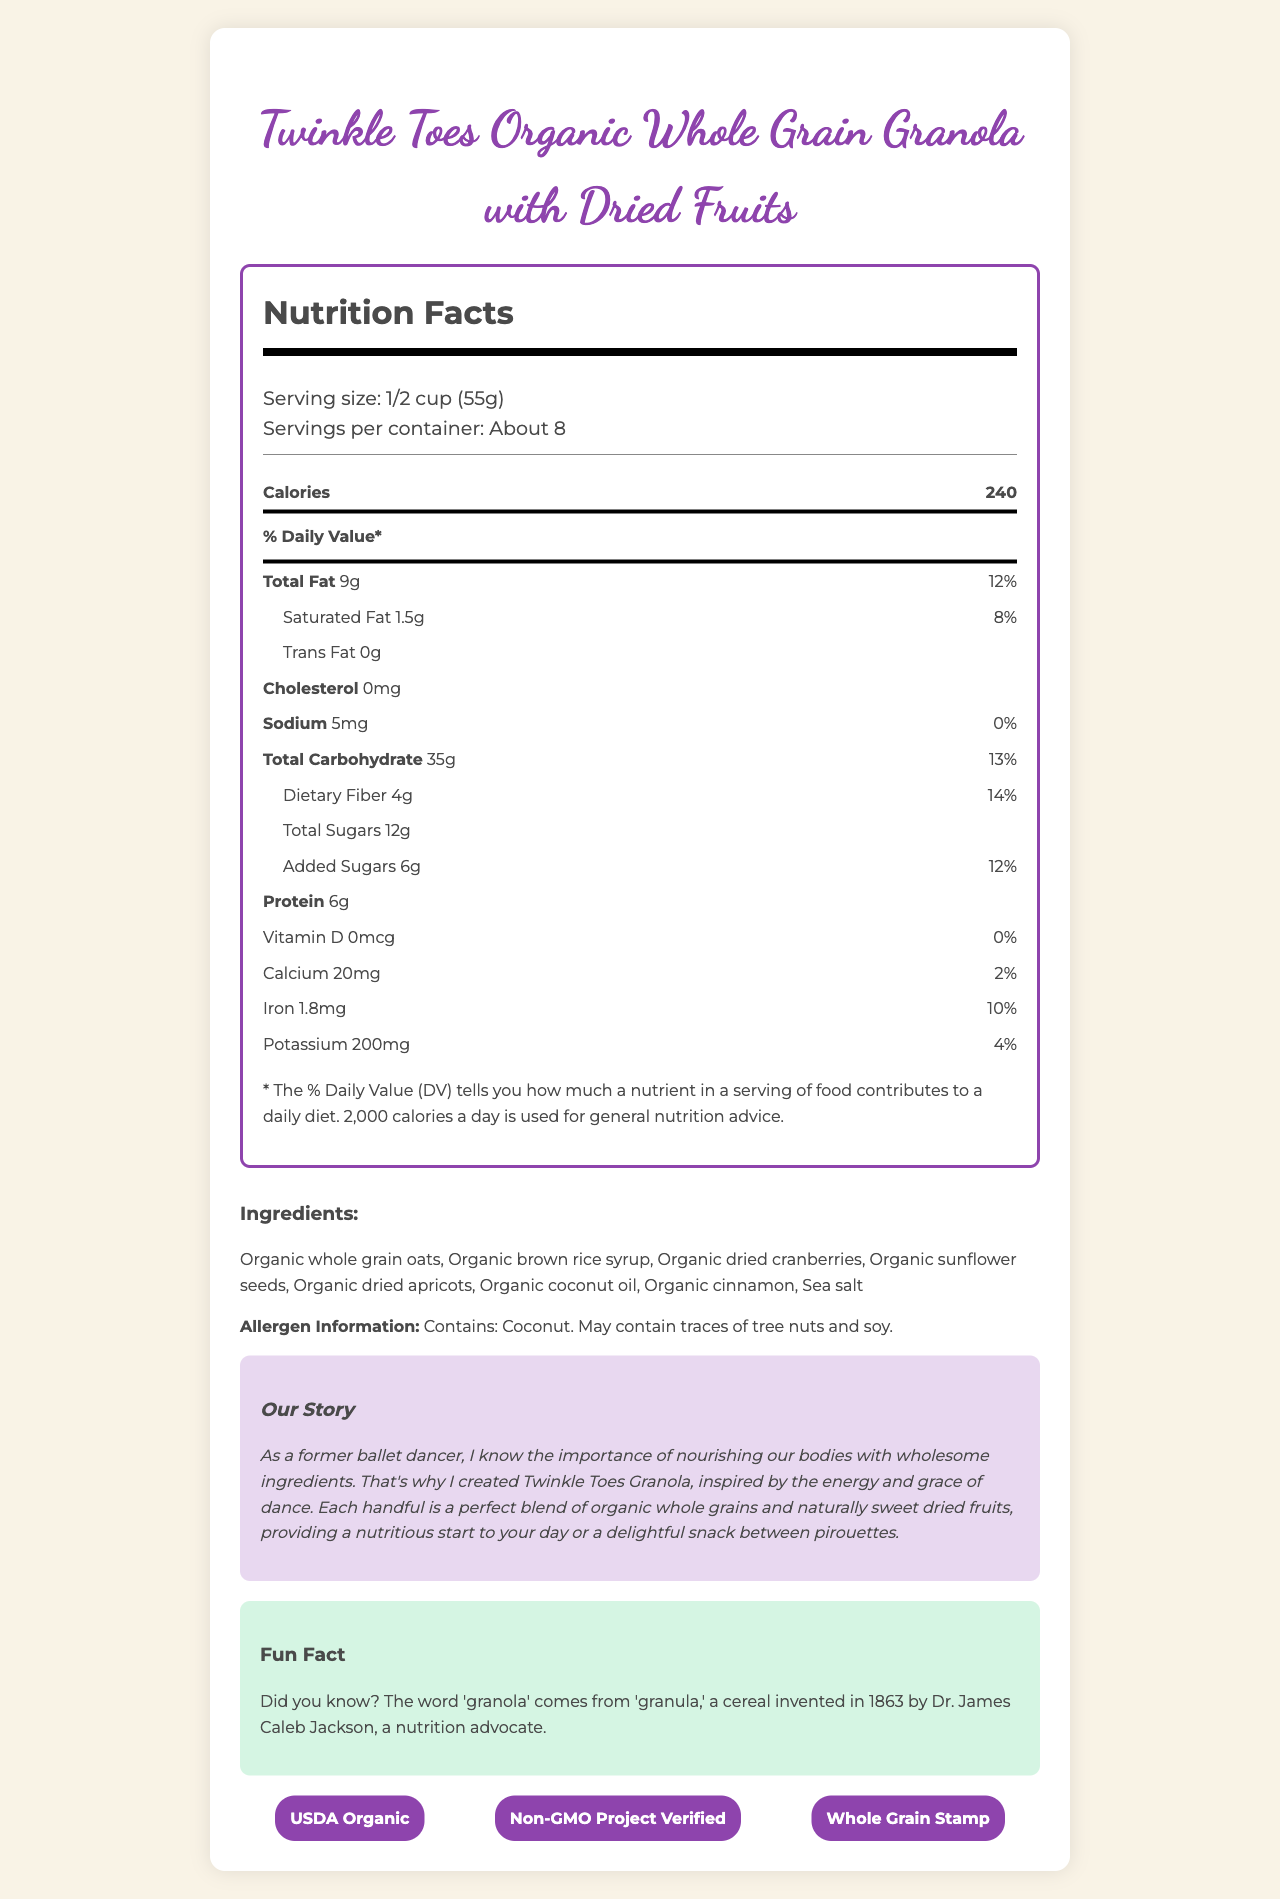what is the serving size? The serving size is mentioned under the "Serving size" heading in the nutrition facts section.
Answer: 1/2 cup (55g) how many calories are in one serving? The calorie count per serving is prominently displayed in the nutrition facts section.
Answer: 240 how much total fat is in one serving? The total fat content is listed in the nutrition facts section.
Answer: 9g how much dietary fiber does one serving contain? The dietary fiber amount is provided in the nutrition facts section.
Answer: 4g how much potassium is in one serving? The potassium content is listed in the nutrition facts section.
Answer: 200mg what's the percentage of daily value for calcium? The daily value percentage for calcium is displayed in the nutrition facts section.
Answer: 2% how many grams of saturated fat are in one serving? The saturated fat content is listed as a sub-category under total fat in the nutrition facts section.
Answer: 1.5g What is the main idea of the document? The document delivers a comprehensive overview of the product, including its nutritional content, ingredients, and additional details like allergen information and a promotional story, to inform consumers about what they are eating.
Answer: The document provides detailed nutritional information for Twinkle Toes Organic Whole Grain Granola with Dried Fruits, including serving size, calories, fat content, carbohydrates, and other nutrients, along with ingredients, allergen information, and background or promotional story. what allergens does this product contain? The allergen information is listed in a separate section labeled "Allergen Information".
Answer: Coconut. May contain traces of tree nuts and soy. what certifications does this product have? A. USDA Organic B. Non-GMO Project Verified C. Whole Grain Stamp D. All of the above The certifications section lists "USDA Organic", "Non-GMO Project Verified", and "Whole Grain Stamp".
Answer: D. All of the above How many servings per container? A. About 6 B. About 8 C. About 10 The servings per container is stated as "About 8" under the serving information.
Answer: B. About 8 Are there any added sugars in the product? The document lists "Added Sugars 6g" in the nutrition facts section.
Answer: Yes What is the source of the product name? The "Our Story" section mentions that the product was inspired by the energy and grace of dance, which is likely the source of the product name "Twinkle Toes".
Answer: Inspired by the energy and grace of dance Is there any information about the sodium content? The sodium content is listed as "5mg" with a daily value percentage of "0%" in the nutrition facts section.
Answer: Yes How much protein does one serving contain? The amount of protein per serving is clearly stated in the nutrition facts section.
Answer: 6g What is the story behind this product? The "Our Story" section explains that the product was created by a former ballet dancer who values nourishing ingredients and was inspired by the energy and grace of dance.
Answer: The creator, a former ballet dancer, emphasizes the importance of nourishing the body with wholesome ingredients and creates the granola inspired by the energy and grace of dance. How many milligrams of cholesterol are there in one serving? The document clearly states that the cholesterol content per serving is "0mg".
Answer: 0mg Are there any sources of Vitamin D in the product? The Vitamin D content is listed as "0mcg" with a daily value percentage of "0%" in the nutrition facts section.
Answer: No What is the fun fact mentioned about granola? The fun fact section explains the origin of the word 'granola'.
Answer: The word 'granola' comes from 'granula,' a cereal invented in 1863 by Dr. James Caleb Jackson, a nutrition advocate. How much of the total carbohydrate is dietary fiber? The document states that the total carbohydrate is 35g and the dietary fiber is separately listed as 4g.
Answer: 4g out of 35g Does the document provide any information on product pricing? The document focuses on nutrition facts, ingredients, certifications, and background story but does not provide any information regarding the price.
Answer: Not enough information 